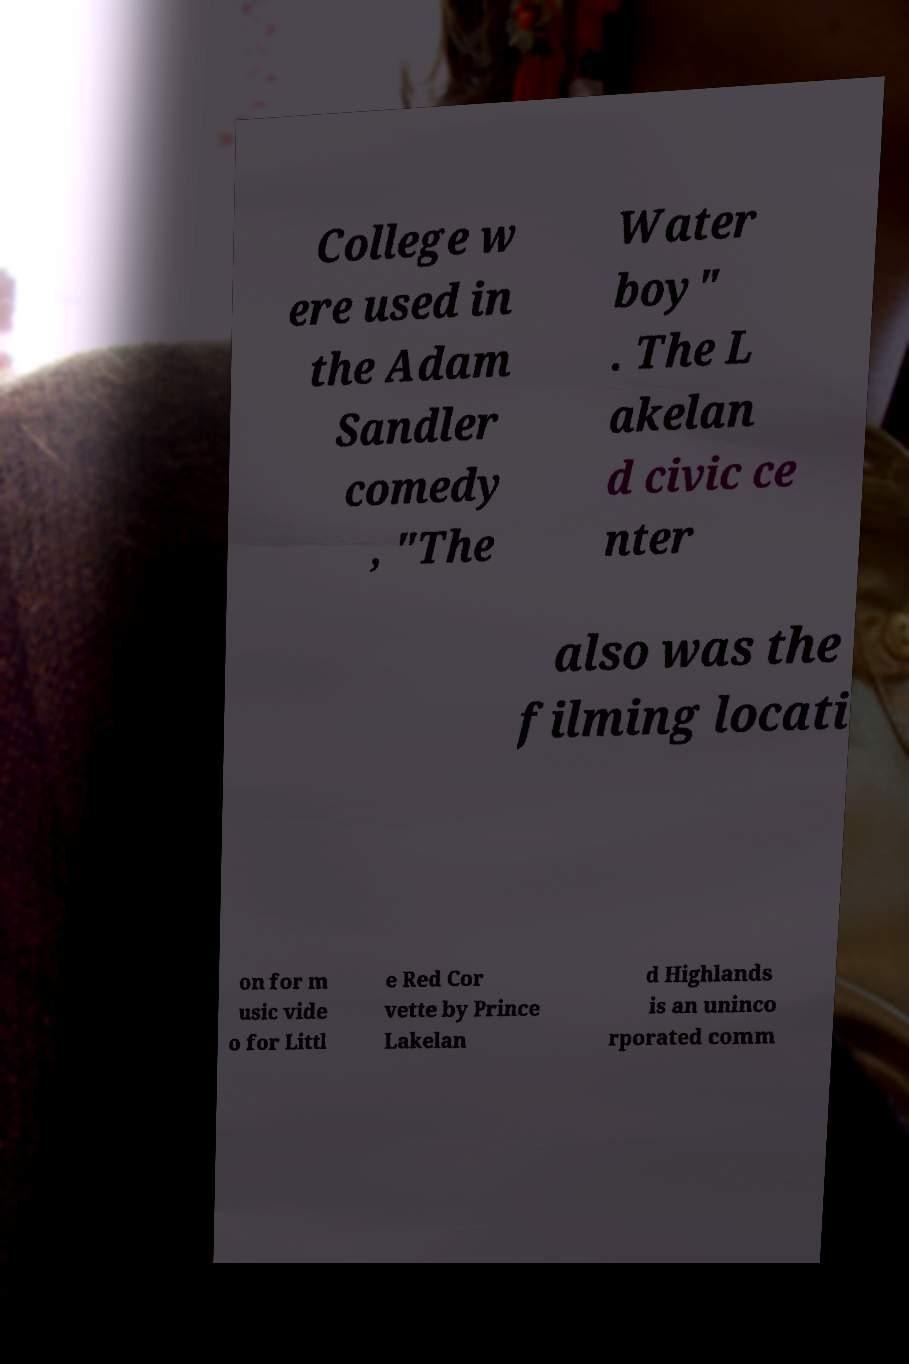There's text embedded in this image that I need extracted. Can you transcribe it verbatim? College w ere used in the Adam Sandler comedy , "The Water boy" . The L akelan d civic ce nter also was the filming locati on for m usic vide o for Littl e Red Cor vette by Prince Lakelan d Highlands is an uninco rporated comm 